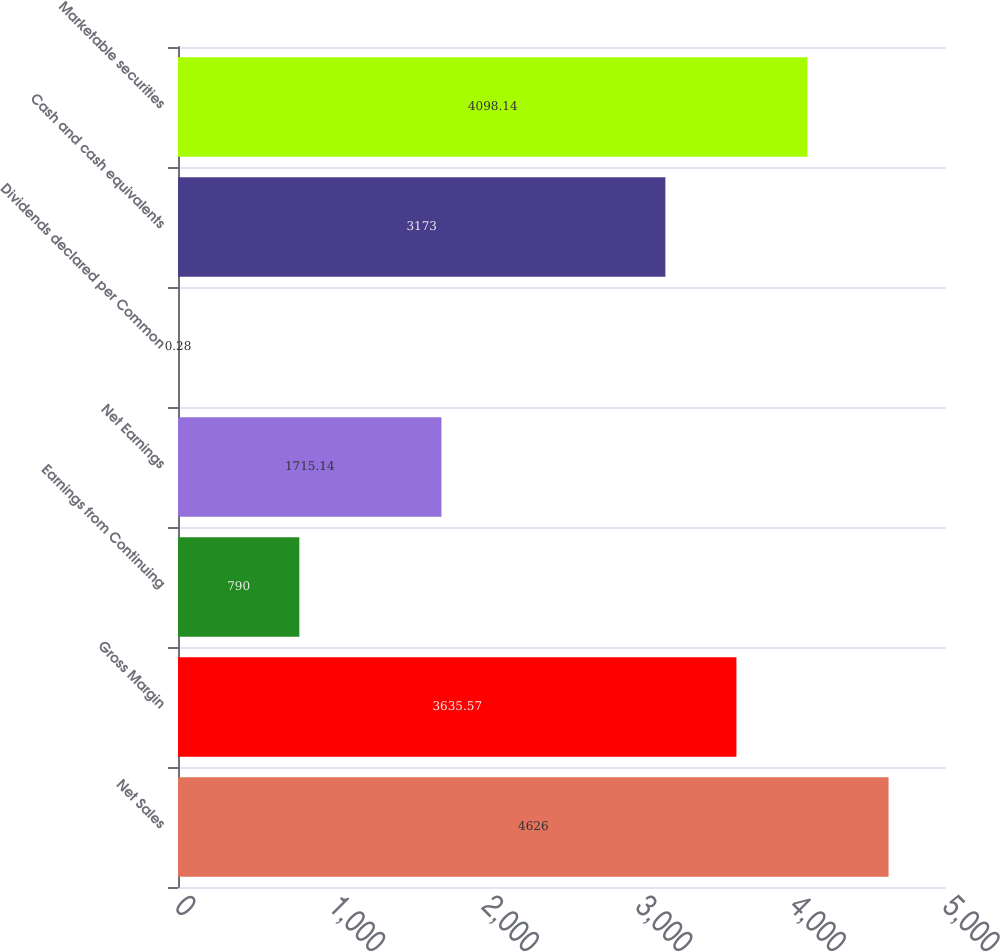<chart> <loc_0><loc_0><loc_500><loc_500><bar_chart><fcel>Net Sales<fcel>Gross Margin<fcel>Earnings from Continuing<fcel>Net Earnings<fcel>Dividends declared per Common<fcel>Cash and cash equivalents<fcel>Marketable securities<nl><fcel>4626<fcel>3635.57<fcel>790<fcel>1715.14<fcel>0.28<fcel>3173<fcel>4098.14<nl></chart> 